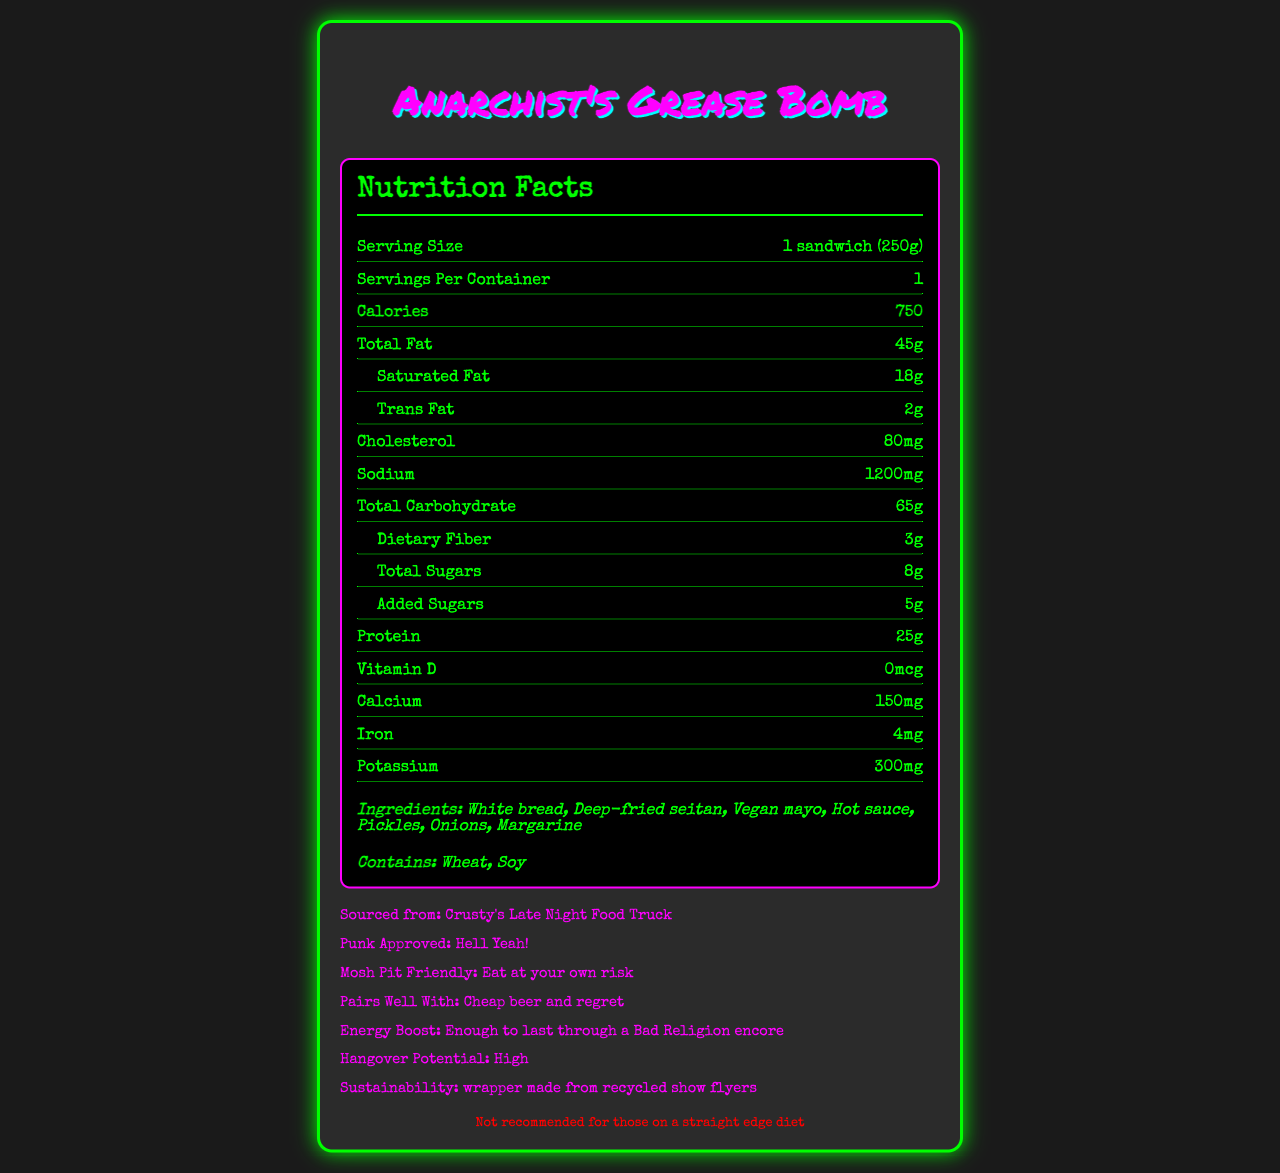what is the serving size of the Anarchist's Grease Bomb? The serving size is clearly stated in the "Serving Size" section of the nutrition label.
Answer: 1 sandwich (250g) how many calories are in one serving? The number of calories is listed directly under the "Calories" section.
Answer: 750 what is the total amount of carbohydrates in the Anarchist's Grease Bomb? The total carbohydrate content is provided in the "Total Carbohydrate" section.
Answer: 65g how much protein does the Anarchist's Grease Bomb contain? The protein content is mentioned in the "Protein" section.
Answer: 25g what are the main allergens in this sandwich? The allergens are specified in the "Contains" section.
Answer: Wheat, Soy how much sodium is in the Anarchist's Grease Bomb? The sodium content is listed under the "Sodium" section.
Answer: 1200mg which nutrient is completely absent in this sandwich? A. Vitamin D B. Calcium C. Iron The "Vitamin D" section states 0mcg, indicating it is absent in the sandwich.
Answer: A. Vitamin D how many grams of saturated fat are in a serving? The label specifies the amount of saturated fat in the "Saturated Fat" section.
Answer: 18g what can you expect after consuming this item? A. Enhanced energy B. Low energy C. No change in energy D. Sleepiness The "Energy Boost" section mentions it provides enough energy to last through a Bad Religion encore.
Answer: A. Enhanced energy is the Anarchist's Grease Bomb mosh pit friendly? The "Mosh Pit Friendly" section gives this warning.
Answer: Eat at your own risk is the wrapper made from sustainable materials? The "Sustainability" section states that the wrapper is made from recycled show flyers.
Answer: Yes summarize the information presented in the document. The document outlines the nutritional content, ingredients, and other attributes of the Anarchist's Grease Bomb, emphasizing its appeal to the punk community.
Answer: The document provides the nutrition facts for the Anarchist's Grease Bomb, a high-calorie sandwich popular at punk shows. It details the serving size, calorie content, and breakdown of various nutrients. The document also lists the ingredients, allergens, and offers additional punk-centric information, including its energy boost, hangover potential, and sustainability features. is this sandwich recommended for someone on a straight edge diet? The disclaimer clearly states, "Not recommended for those on a straight edge diet."
Answer: No what is the source of this sandwich? The "Sourced from" section indicates the sandwich comes from Crusty's Late Night Food Truck.
Answer: Crusty's Late Night Food Truck Who produced the music you hear at night punk shows? The document provides nutritional information and related details about the sandwich but does not mention anything about music production.
Answer: Cannot be determined 